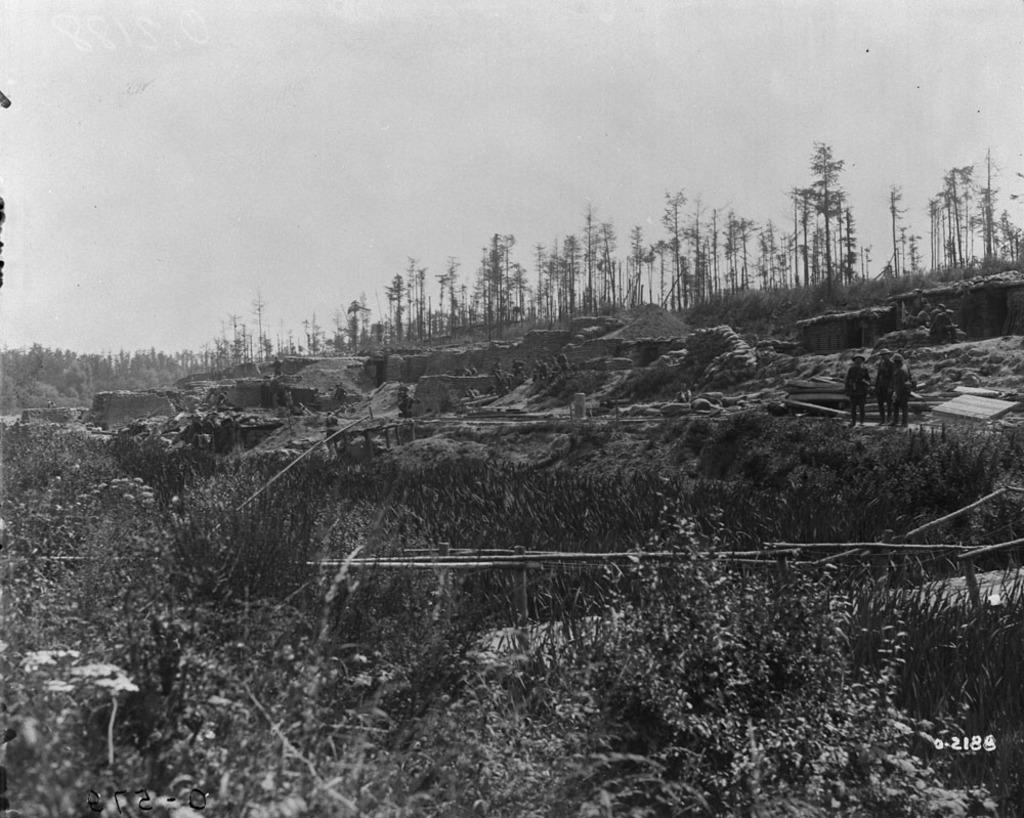What type of natural elements are present in the image? There are many trees and plants in the image. What can be seen in the background of the image? There are walls in the background of the image. How many people are in the image? There are three persons in the image. What is visible at the top of the image? The sky is visible at the top of the image. Can you see a giraffe eating a bead in the image? There is no giraffe or bead present in the image. 